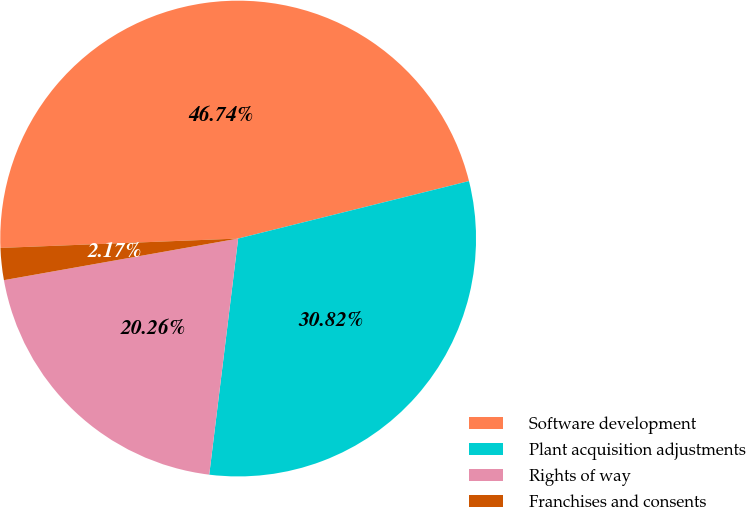Convert chart. <chart><loc_0><loc_0><loc_500><loc_500><pie_chart><fcel>Software development<fcel>Plant acquisition adjustments<fcel>Rights of way<fcel>Franchises and consents<nl><fcel>46.74%<fcel>30.82%<fcel>20.26%<fcel>2.17%<nl></chart> 